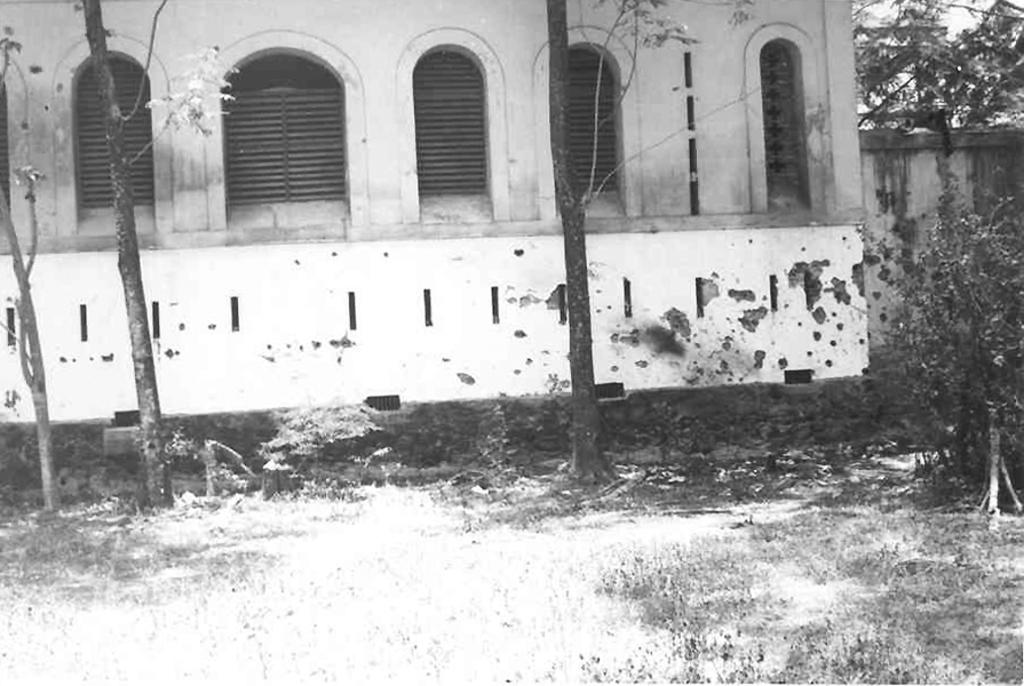What is the color scheme of the image? The image is black and white. What type of vegetation can be seen in the image? There is grass in the image. What other natural elements are present in the image? There are trees in the image. What type of man-made structures can be seen in the image? There is a wall and a building with windows in the image. Can you tell me how many secretaries are working in the building in the image? There is no indication of any secretaries or their work in the image; it only shows a building with windows. 